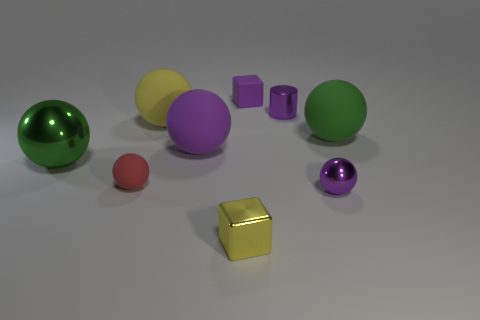Subtract all purple spheres. How many spheres are left? 4 Subtract all yellow balls. How many balls are left? 5 Subtract all blocks. How many objects are left? 7 Add 1 purple metallic cylinders. How many objects exist? 10 Subtract all blue cubes. How many green spheres are left? 2 Add 4 red balls. How many red balls exist? 5 Subtract 0 blue blocks. How many objects are left? 9 Subtract 4 spheres. How many spheres are left? 2 Subtract all gray spheres. Subtract all green blocks. How many spheres are left? 6 Subtract all tiny purple rubber things. Subtract all big gray metallic cylinders. How many objects are left? 8 